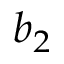<formula> <loc_0><loc_0><loc_500><loc_500>b _ { 2 }</formula> 